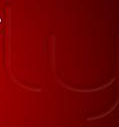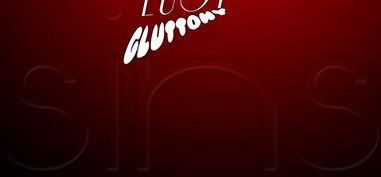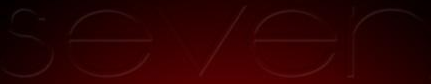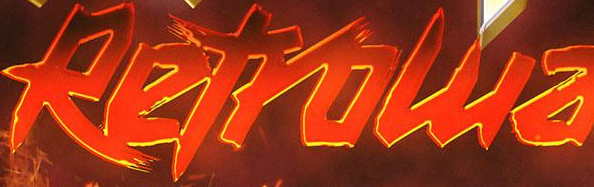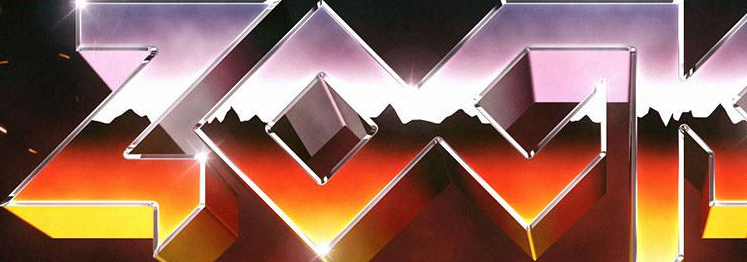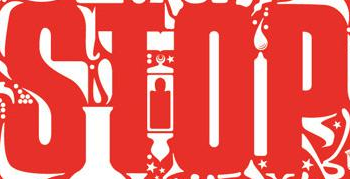What words can you see in these images in sequence, separated by a semicolon? ly; sins; sever; Retrowa; ZOCK; STOP 